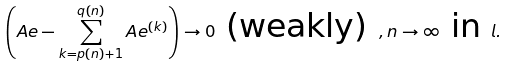Convert formula to latex. <formula><loc_0><loc_0><loc_500><loc_500>\left ( A e - \sum _ { k = p ( n ) + 1 } ^ { q ( n ) } A e ^ { ( k ) } \right ) \to 0 \text { (weakly) } , n \to \infty \text { in } l .</formula> 